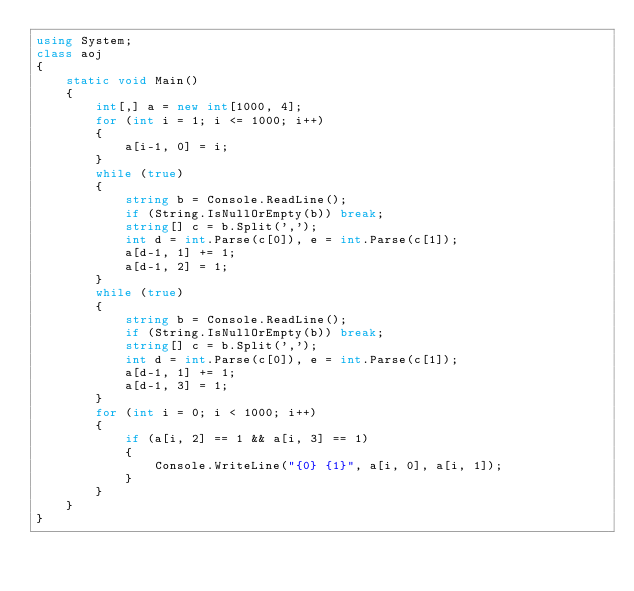<code> <loc_0><loc_0><loc_500><loc_500><_C#_>using System;
class aoj
{
    static void Main()
    {
        int[,] a = new int[1000, 4];
        for (int i = 1; i <= 1000; i++)
        {
            a[i-1, 0] = i;
        }
        while (true)
        {
            string b = Console.ReadLine();
            if (String.IsNullOrEmpty(b)) break;
            string[] c = b.Split(',');
            int d = int.Parse(c[0]), e = int.Parse(c[1]);
            a[d-1, 1] += 1;
            a[d-1, 2] = 1;
        }
        while (true)
        {
            string b = Console.ReadLine();
            if (String.IsNullOrEmpty(b)) break;
            string[] c = b.Split(',');
            int d = int.Parse(c[0]), e = int.Parse(c[1]);
            a[d-1, 1] += 1;
            a[d-1, 3] = 1;
        }
        for (int i = 0; i < 1000; i++)
        {
            if (a[i, 2] == 1 && a[i, 3] == 1)
            {
                Console.WriteLine("{0} {1}", a[i, 0], a[i, 1]);
            }
        }
    }
}</code> 